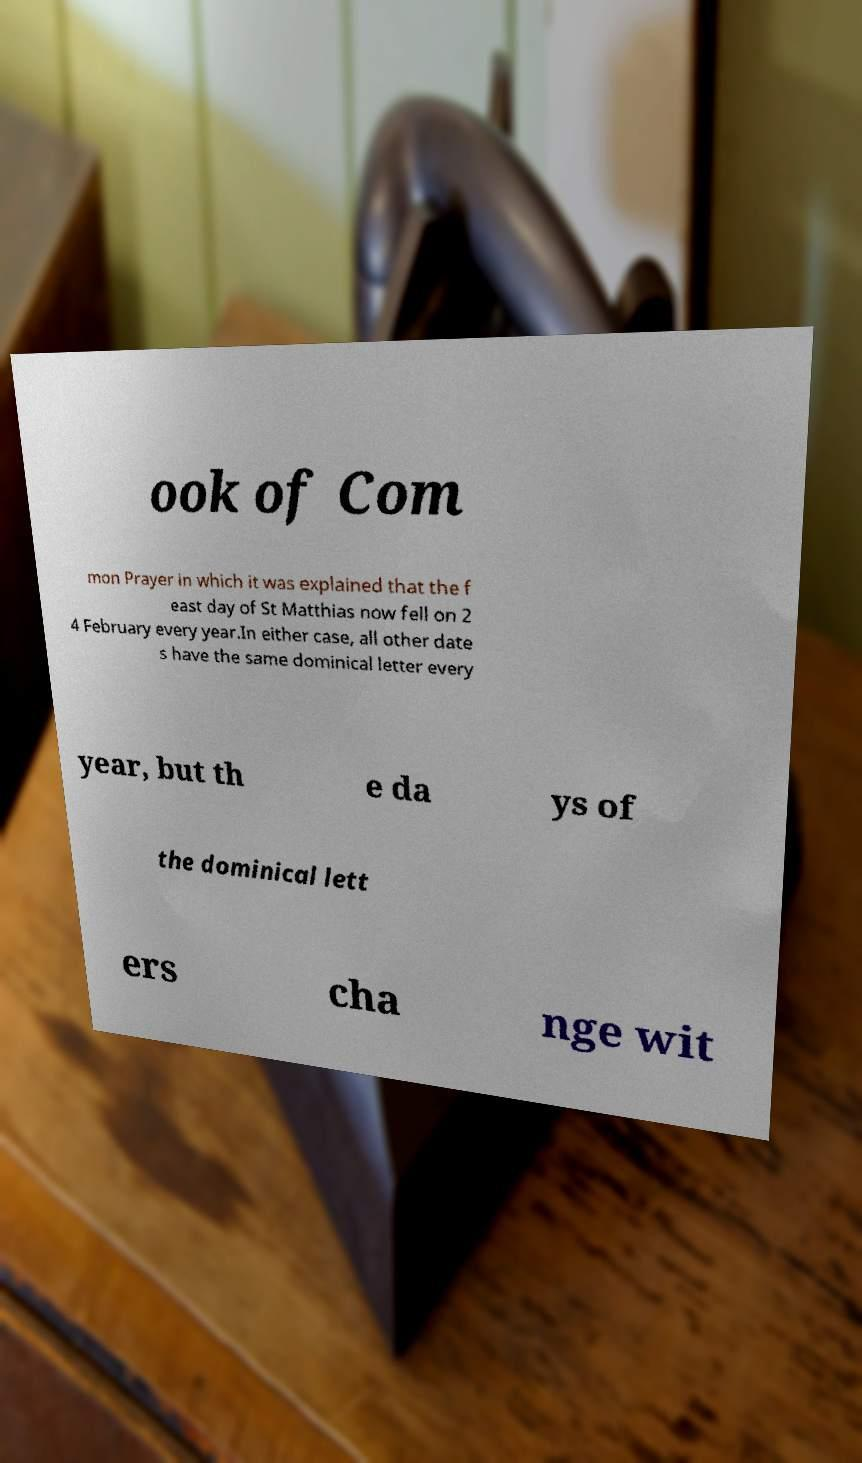Could you extract and type out the text from this image? ook of Com mon Prayer in which it was explained that the f east day of St Matthias now fell on 2 4 February every year.In either case, all other date s have the same dominical letter every year, but th e da ys of the dominical lett ers cha nge wit 